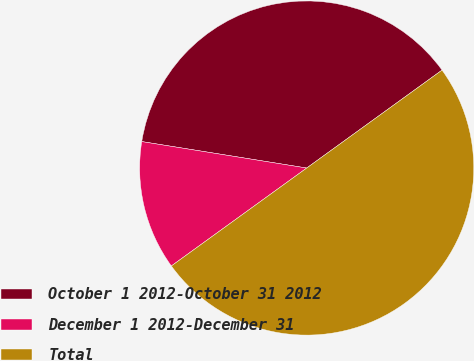<chart> <loc_0><loc_0><loc_500><loc_500><pie_chart><fcel>October 1 2012-October 31 2012<fcel>December 1 2012-December 31<fcel>Total<nl><fcel>37.5%<fcel>12.5%<fcel>50.0%<nl></chart> 